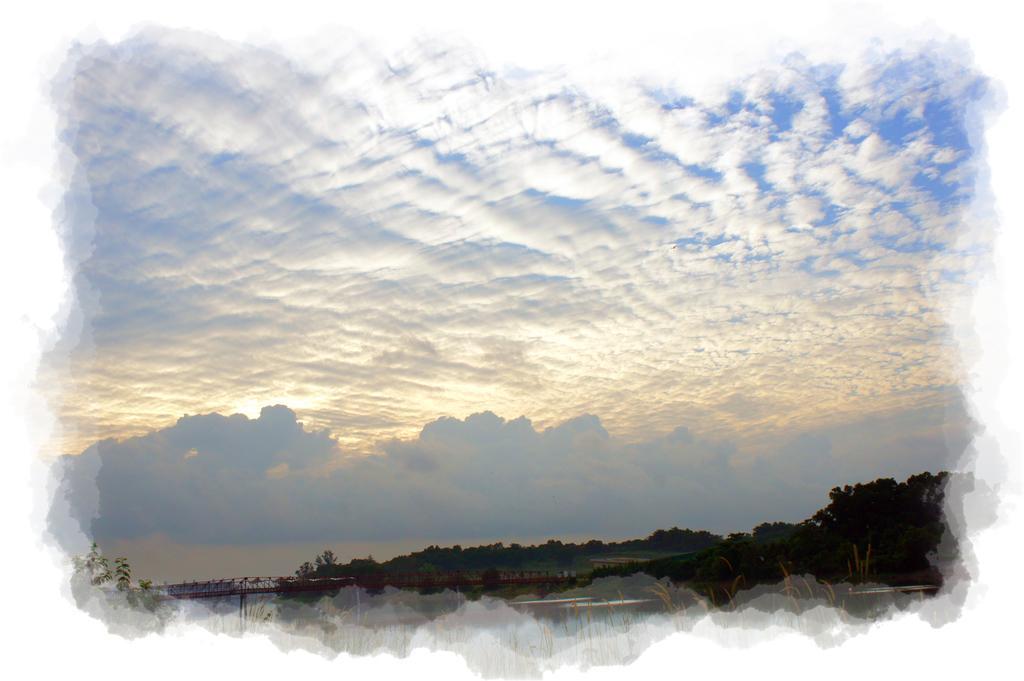Please provide a concise description of this image. In this image I can see few trees, at left I can see a bridge and the sky is in blue and white color. 